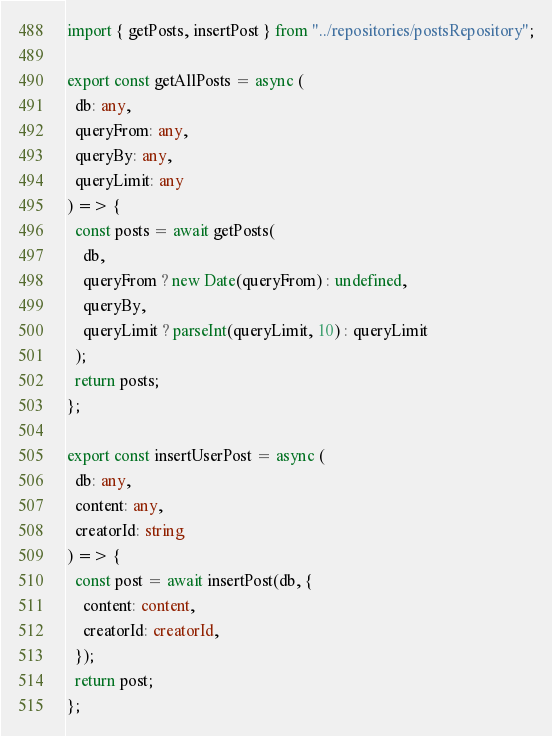Convert code to text. <code><loc_0><loc_0><loc_500><loc_500><_TypeScript_>import { getPosts, insertPost } from "../repositories/postsRepository";

export const getAllPosts = async (
  db: any,
  queryFrom: any,
  queryBy: any,
  queryLimit: any
) => {
  const posts = await getPosts(
    db,
    queryFrom ? new Date(queryFrom) : undefined,
    queryBy,
    queryLimit ? parseInt(queryLimit, 10) : queryLimit
  );
  return posts;
};

export const insertUserPost = async (
  db: any,
  content: any,
  creatorId: string
) => {
  const post = await insertPost(db, {
    content: content,
    creatorId: creatorId,
  });
  return post;
};
</code> 